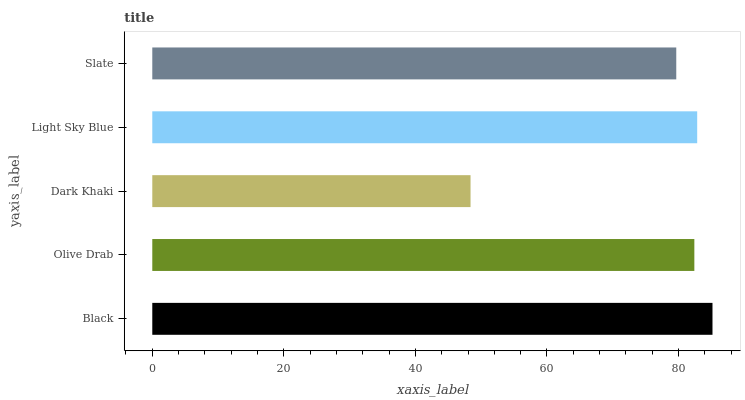Is Dark Khaki the minimum?
Answer yes or no. Yes. Is Black the maximum?
Answer yes or no. Yes. Is Olive Drab the minimum?
Answer yes or no. No. Is Olive Drab the maximum?
Answer yes or no. No. Is Black greater than Olive Drab?
Answer yes or no. Yes. Is Olive Drab less than Black?
Answer yes or no. Yes. Is Olive Drab greater than Black?
Answer yes or no. No. Is Black less than Olive Drab?
Answer yes or no. No. Is Olive Drab the high median?
Answer yes or no. Yes. Is Olive Drab the low median?
Answer yes or no. Yes. Is Slate the high median?
Answer yes or no. No. Is Light Sky Blue the low median?
Answer yes or no. No. 